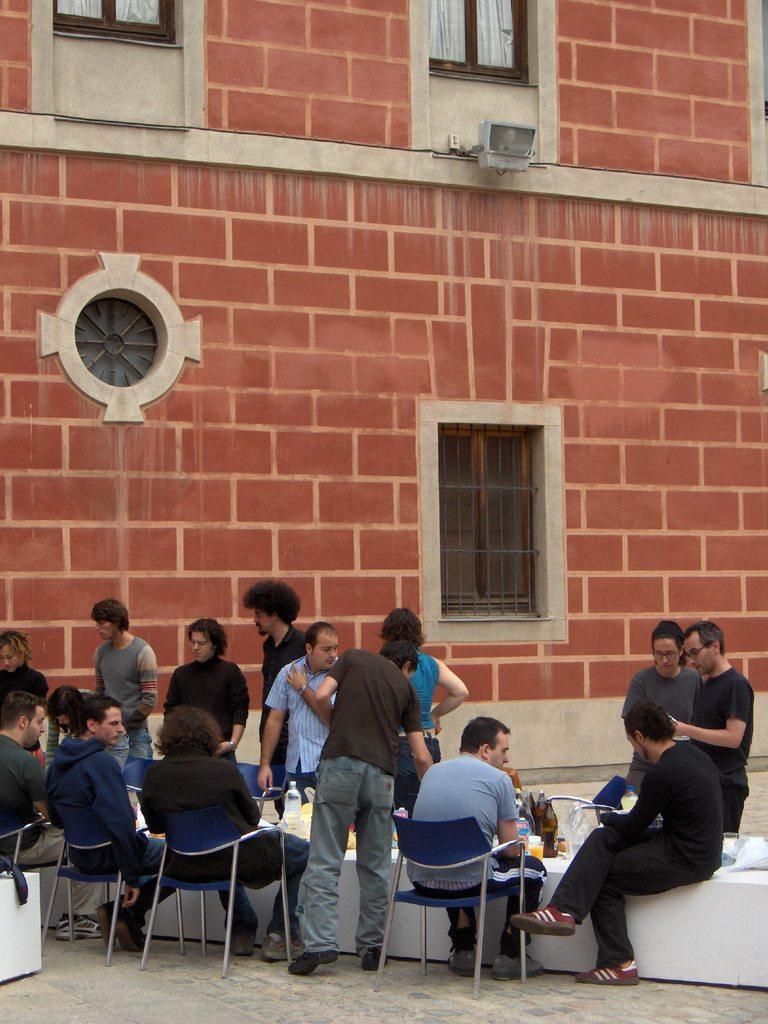How would you summarize this image in a sentence or two? In this image, there are a few people. Among them, some people are sitting on chairs. We can also see a white colored object with some bottles. We can see the ground and some objects on the left. We can also see the wall with a few windows and curtains. We can also see an object attached to the wall. 